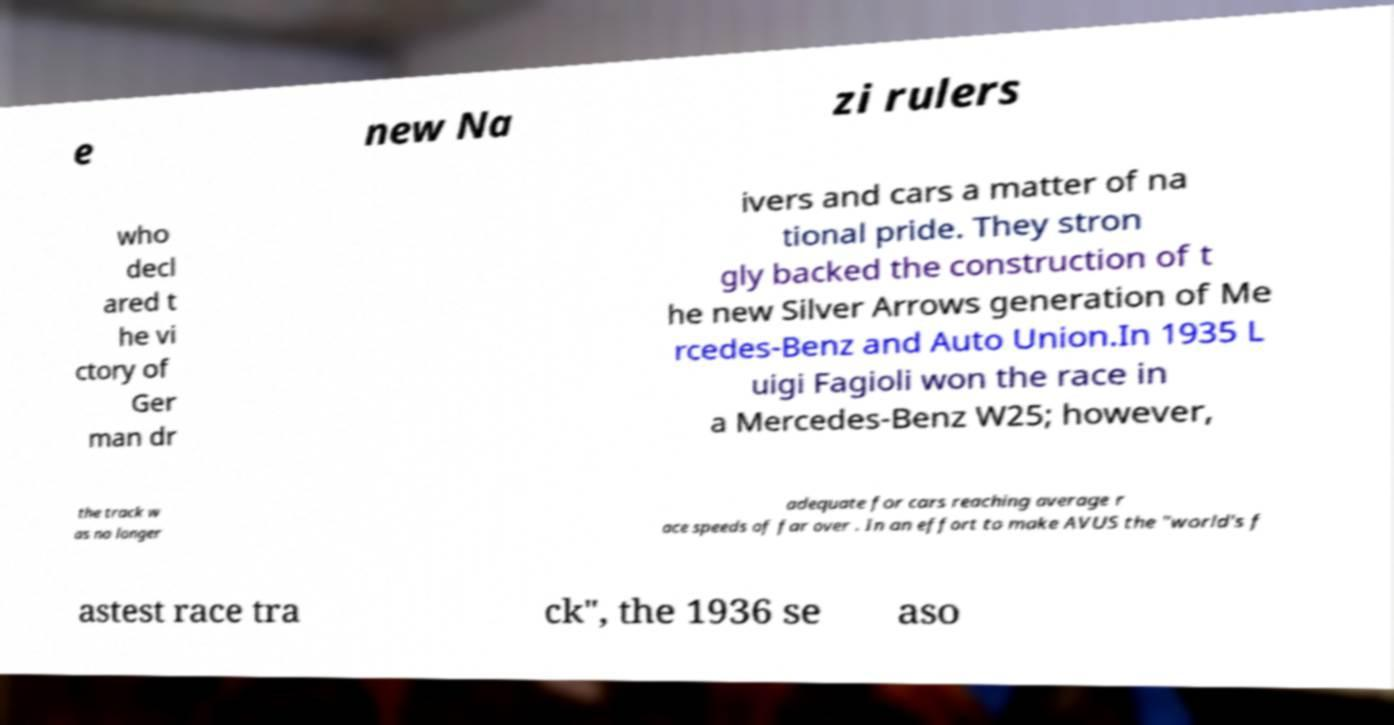Please identify and transcribe the text found in this image. e new Na zi rulers who decl ared t he vi ctory of Ger man dr ivers and cars a matter of na tional pride. They stron gly backed the construction of t he new Silver Arrows generation of Me rcedes-Benz and Auto Union.In 1935 L uigi Fagioli won the race in a Mercedes-Benz W25; however, the track w as no longer adequate for cars reaching average r ace speeds of far over . In an effort to make AVUS the "world's f astest race tra ck", the 1936 se aso 